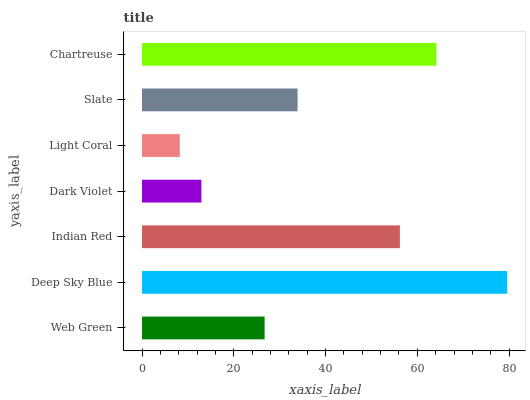Is Light Coral the minimum?
Answer yes or no. Yes. Is Deep Sky Blue the maximum?
Answer yes or no. Yes. Is Indian Red the minimum?
Answer yes or no. No. Is Indian Red the maximum?
Answer yes or no. No. Is Deep Sky Blue greater than Indian Red?
Answer yes or no. Yes. Is Indian Red less than Deep Sky Blue?
Answer yes or no. Yes. Is Indian Red greater than Deep Sky Blue?
Answer yes or no. No. Is Deep Sky Blue less than Indian Red?
Answer yes or no. No. Is Slate the high median?
Answer yes or no. Yes. Is Slate the low median?
Answer yes or no. Yes. Is Deep Sky Blue the high median?
Answer yes or no. No. Is Light Coral the low median?
Answer yes or no. No. 